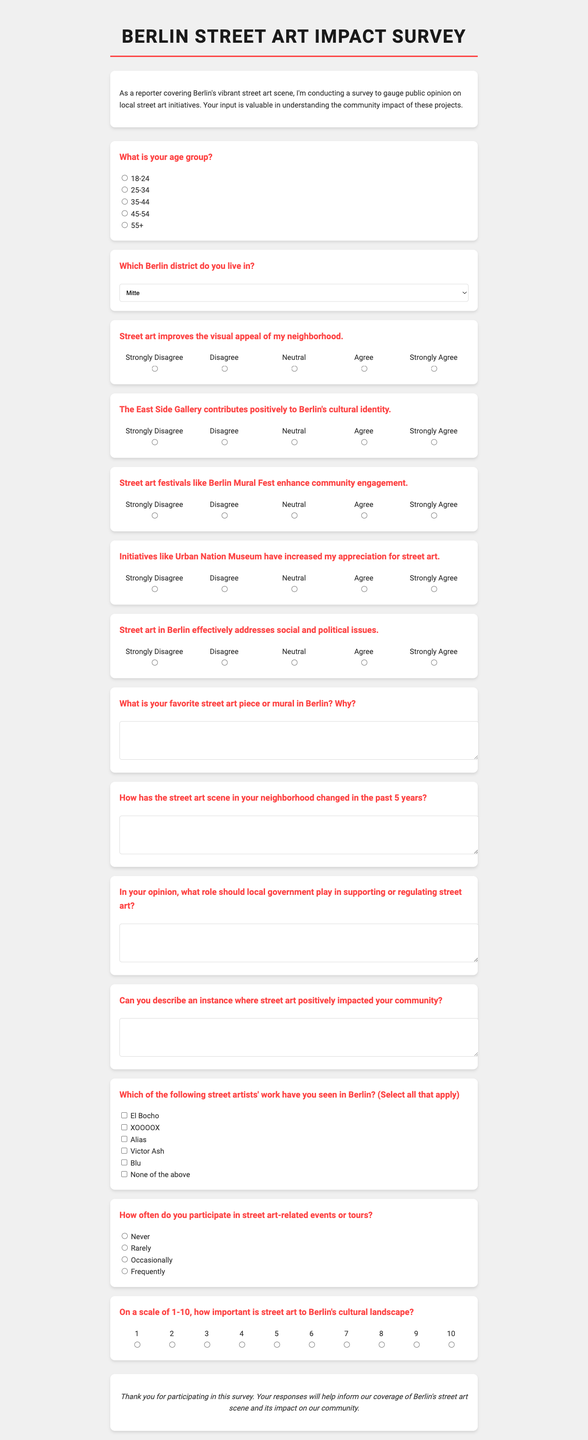What is the title of the form? The title is the main heading of the document and is stated at the top.
Answer: Berlin Street Art Impact Survey What age group options are provided? This information includes categories for respondents' ages listed in the demographic section.
Answer: 18-24, 25-34, 35-44, 45-54, 55+ How many Likert scale questions are included? This is the count of specific questions that use a scale for response in the document.
Answer: 5 What is the first question in the Likert scale section? This is identified as the initial query posed to respondents in the Likert scale format.
Answer: Street art improves the visual appeal of my neighborhood What type of response is required for the question about favorite street art? This indicates the format of the answer expected from the respondent for that particular question.
Answer: Open-ended response What role is suggested for local government in relation to street art? This pertains to the responsibilities or actions that respondents can envision for local authorities regarding street art, as stated in one of the questions.
Answer: Supporting or regulating street art 